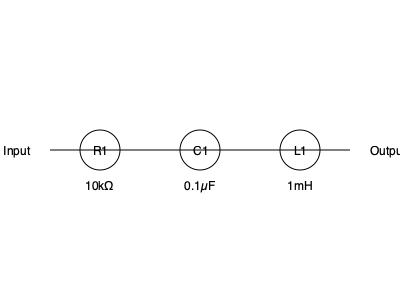In the given audio circuit diagram, what type of filter is represented, and what is its primary function in sound processing? To determine the type of filter and its function, let's analyze the circuit components and their arrangement:

1. The circuit consists of three components in series: a resistor (R1), a capacitor (C1), and an inductor (L1).

2. The order of components is important: R-C-L (Resistor-Capacitor-Inductor).

3. This configuration is known as an RLC circuit, specifically a series RLC circuit.

4. In the context of audio processing, this arrangement forms a band-pass filter.

5. A band-pass filter allows a specific range of frequencies to pass through while attenuating frequencies outside this range.

6. The resistor (R1) helps control the bandwidth of the filter.

7. The capacitor (C1) blocks low frequencies.

8. The inductor (L1) blocks high frequencies.

9. The combination of these components creates a frequency response curve that peaks at a specific center frequency, allowing a "band" of frequencies around this center to pass through.

10. In sound processing, band-pass filters are used to isolate specific frequency ranges, which can be useful for:
    - Focusing on particular instrument ranges
    - Eliminating unwanted noise outside the desired frequency band
    - Shaping the tonal characteristics of audio signals

Therefore, this circuit represents a band-pass filter, primarily used to isolate and enhance a specific range of frequencies in an audio signal.
Answer: Band-pass filter; isolates specific frequency range 